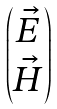<formula> <loc_0><loc_0><loc_500><loc_500>\begin{pmatrix} \vec { E } \\ \vec { H } \end{pmatrix}</formula> 